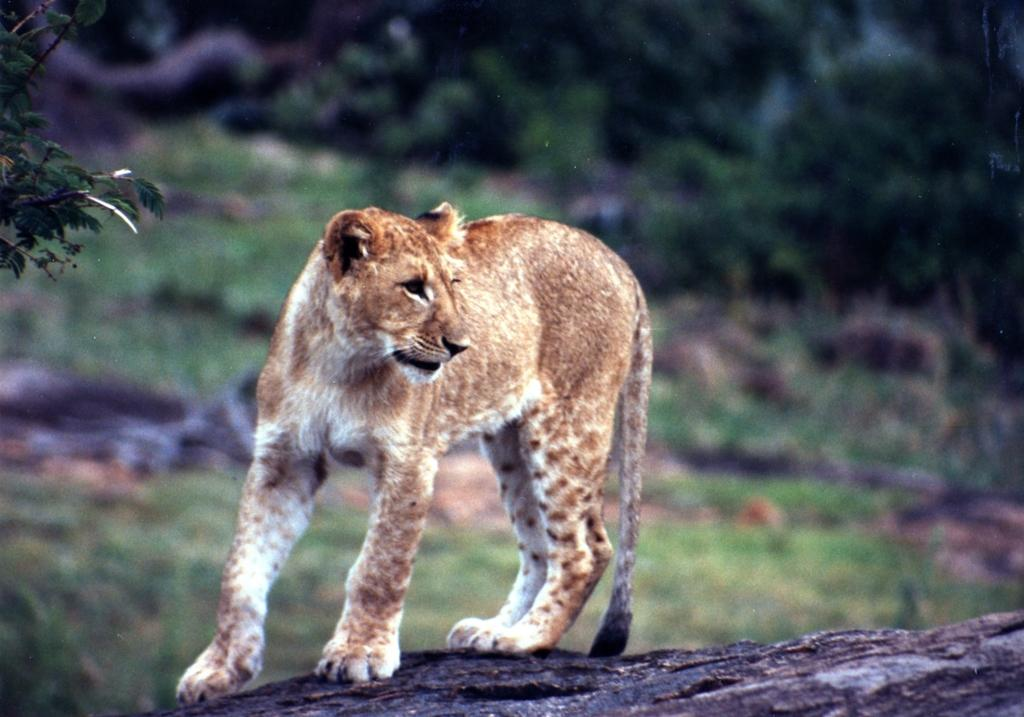What animal is the main subject of the image? There is a tiger in the image. What is the tiger's position in the image? The tiger is standing on the ground. What can be seen in the background of the image? There is a group of trees in the background of the image. How many plastic cherries are scattered around the tiger in the image? There are no plastic cherries present in the image. 